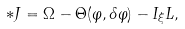Convert formula to latex. <formula><loc_0><loc_0><loc_500><loc_500>\ast J = \Omega - \Theta ( \varphi , \delta \varphi ) - I _ { \xi } L ,</formula> 